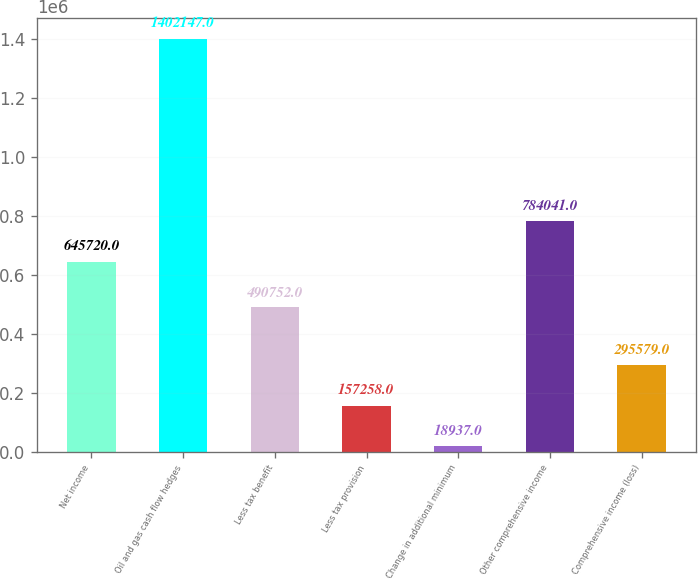<chart> <loc_0><loc_0><loc_500><loc_500><bar_chart><fcel>Net income<fcel>Oil and gas cash flow hedges<fcel>Less tax benefit<fcel>Less tax provision<fcel>Change in additional minimum<fcel>Other comprehensive income<fcel>Comprehensive income (loss)<nl><fcel>645720<fcel>1.40215e+06<fcel>490752<fcel>157258<fcel>18937<fcel>784041<fcel>295579<nl></chart> 